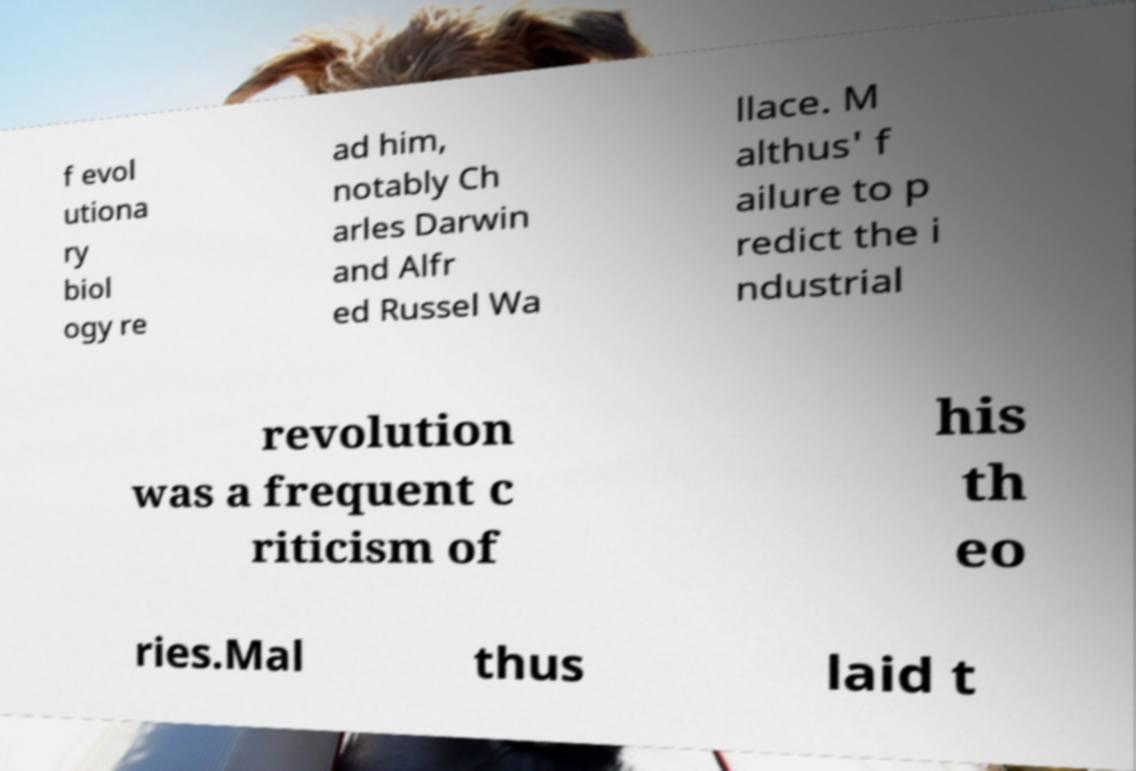Could you extract and type out the text from this image? f evol utiona ry biol ogy re ad him, notably Ch arles Darwin and Alfr ed Russel Wa llace. M althus' f ailure to p redict the i ndustrial revolution was a frequent c riticism of his th eo ries.Mal thus laid t 